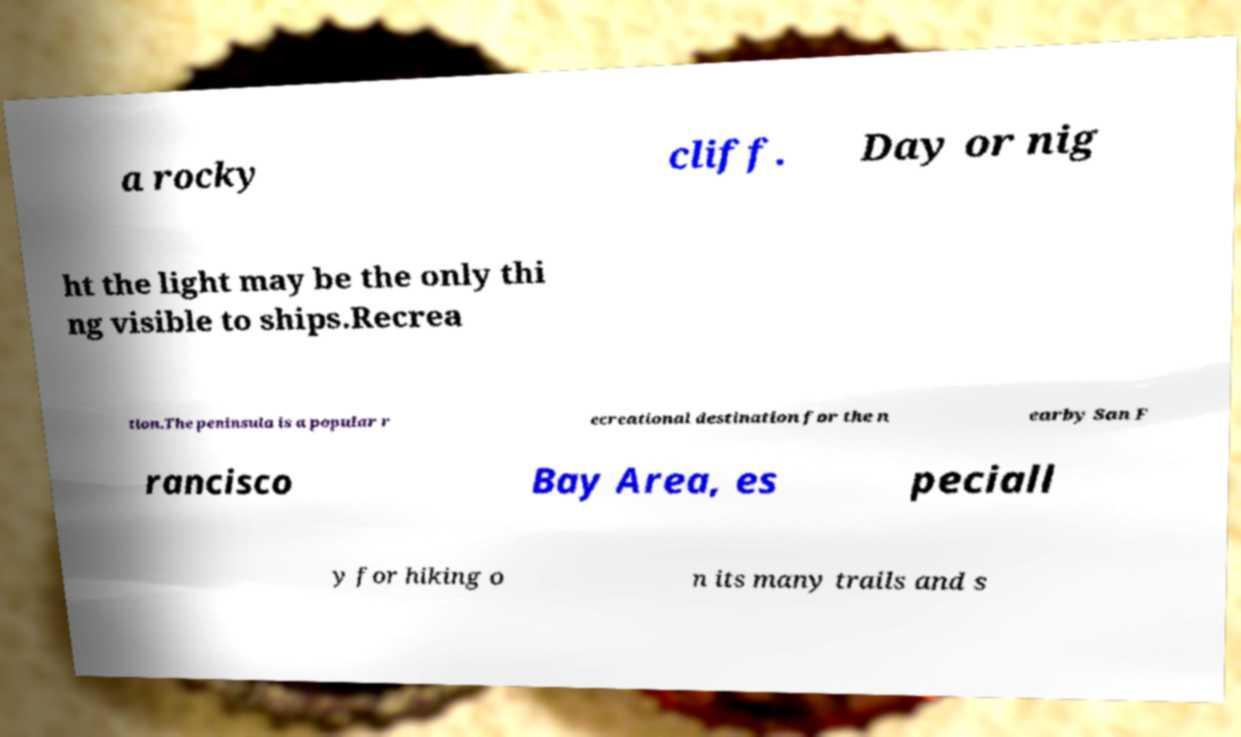Please read and relay the text visible in this image. What does it say? a rocky cliff. Day or nig ht the light may be the only thi ng visible to ships.Recrea tion.The peninsula is a popular r ecreational destination for the n earby San F rancisco Bay Area, es peciall y for hiking o n its many trails and s 